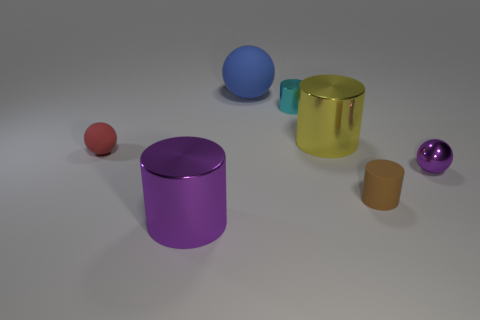Add 1 small blue spheres. How many objects exist? 8 Subtract all cylinders. How many objects are left? 3 Add 6 blue matte objects. How many blue matte objects are left? 7 Add 3 blue rubber things. How many blue rubber things exist? 4 Subtract 0 yellow blocks. How many objects are left? 7 Subtract all tiny shiny cylinders. Subtract all purple metallic cylinders. How many objects are left? 5 